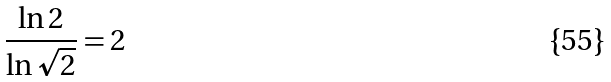Convert formula to latex. <formula><loc_0><loc_0><loc_500><loc_500>\frac { \ln 2 } { \ln \sqrt { 2 } } = 2</formula> 